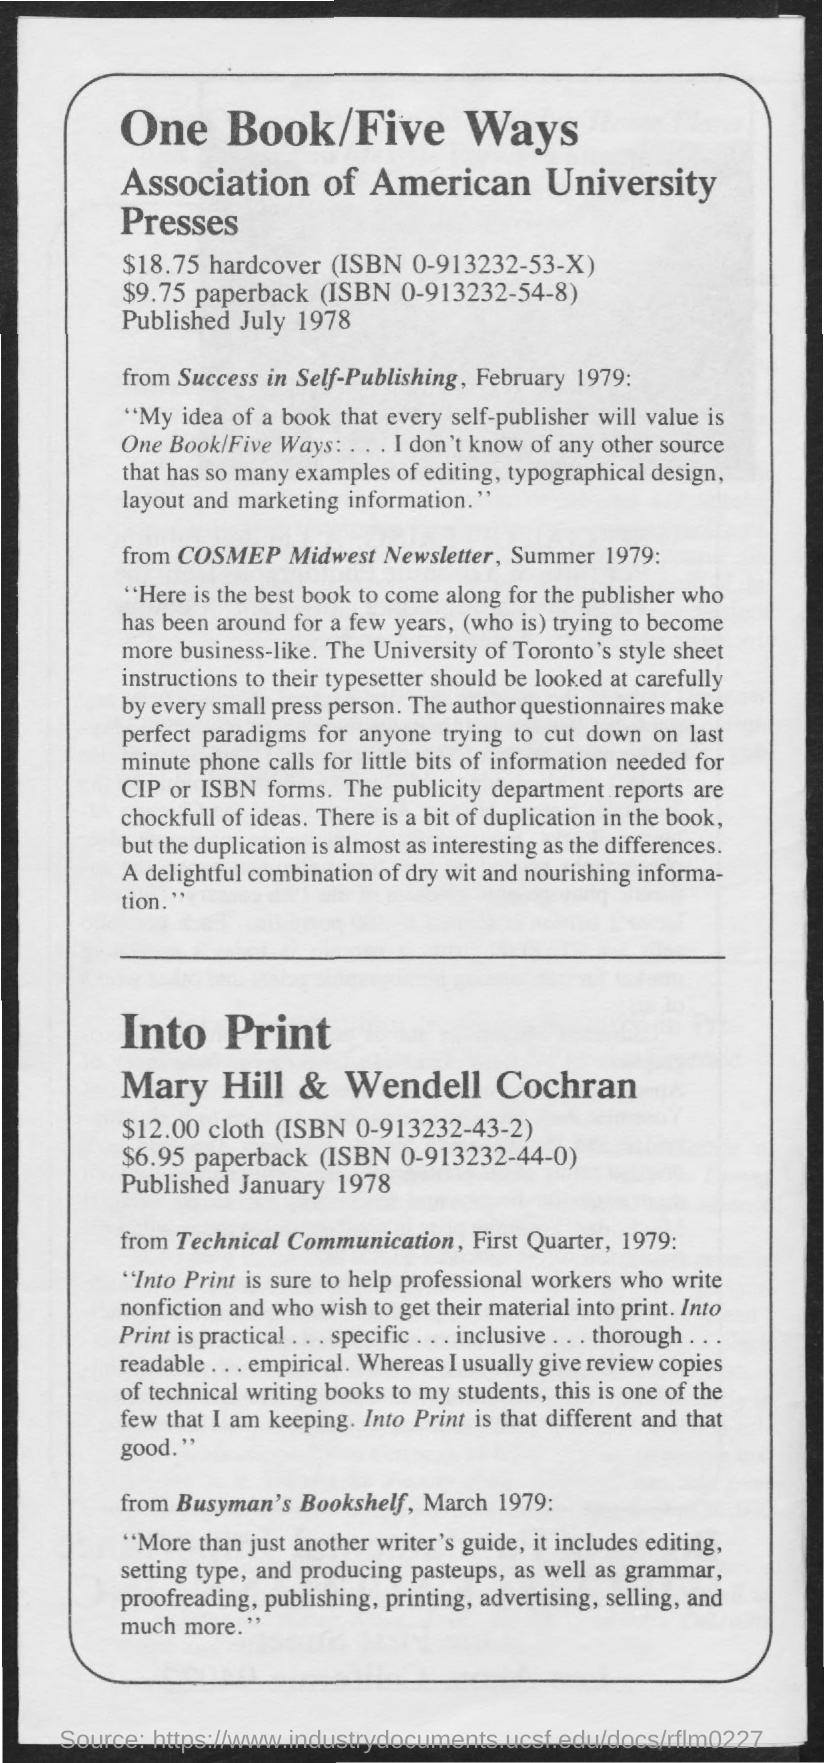Highlight a few significant elements in this photo. The One Book/Five Ways was published in July 1978. 